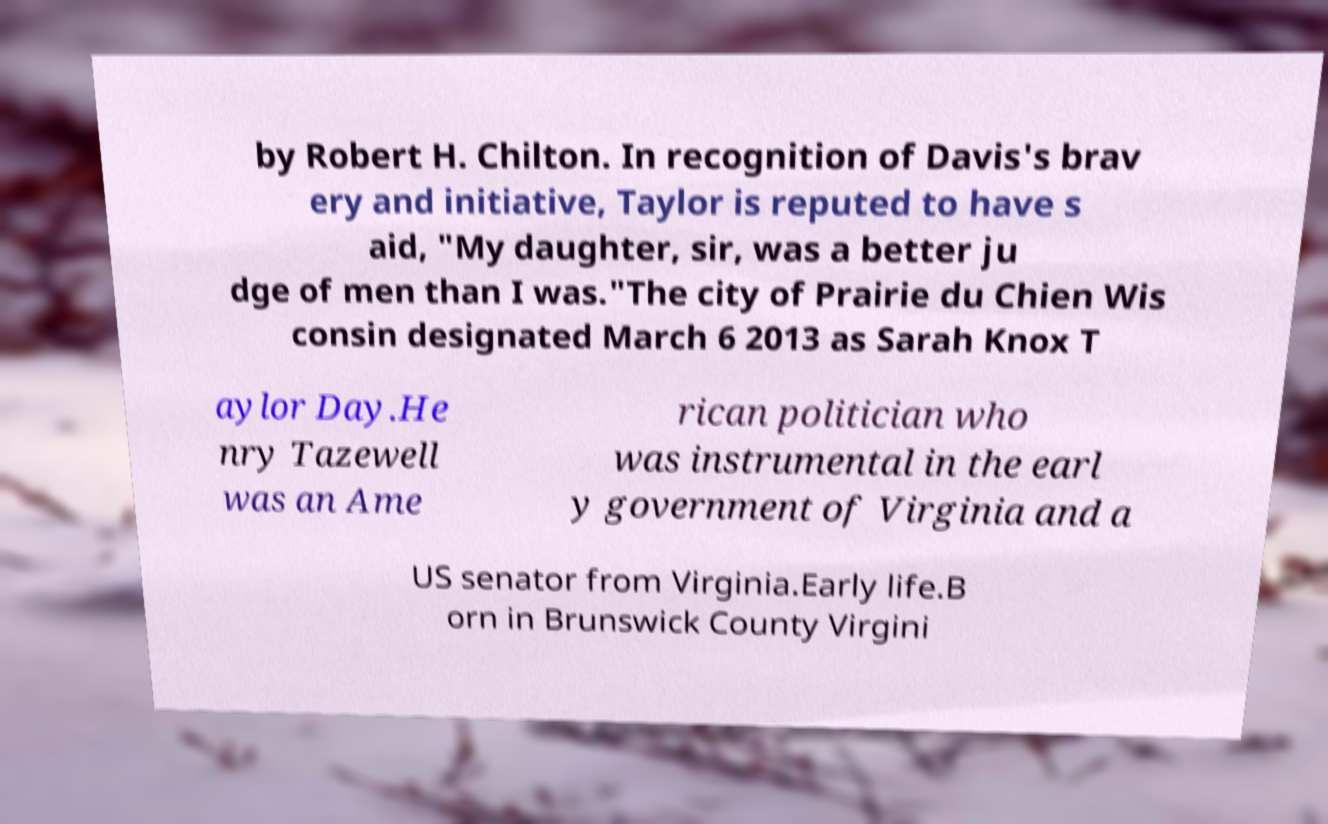Can you read and provide the text displayed in the image?This photo seems to have some interesting text. Can you extract and type it out for me? by Robert H. Chilton. In recognition of Davis's brav ery and initiative, Taylor is reputed to have s aid, "My daughter, sir, was a better ju dge of men than I was."The city of Prairie du Chien Wis consin designated March 6 2013 as Sarah Knox T aylor Day.He nry Tazewell was an Ame rican politician who was instrumental in the earl y government of Virginia and a US senator from Virginia.Early life.B orn in Brunswick County Virgini 